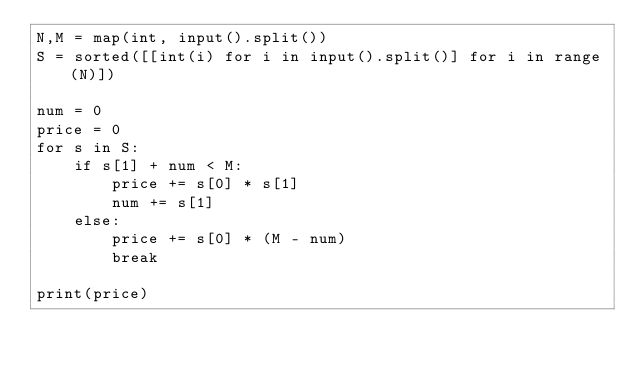Convert code to text. <code><loc_0><loc_0><loc_500><loc_500><_Python_>N,M = map(int, input().split())
S = sorted([[int(i) for i in input().split()] for i in range(N)])

num = 0
price = 0
for s in S:
	if s[1] + num < M:
		price += s[0] * s[1]
		num += s[1]
	else:
		price += s[0] * (M - num)
		break
    
print(price)</code> 